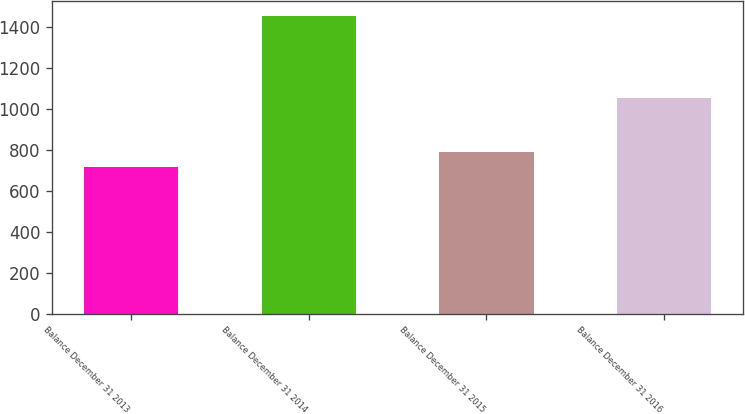<chart> <loc_0><loc_0><loc_500><loc_500><bar_chart><fcel>Balance December 31 2013<fcel>Balance December 31 2014<fcel>Balance December 31 2015<fcel>Balance December 31 2016<nl><fcel>719<fcel>1455<fcel>792.6<fcel>1056<nl></chart> 